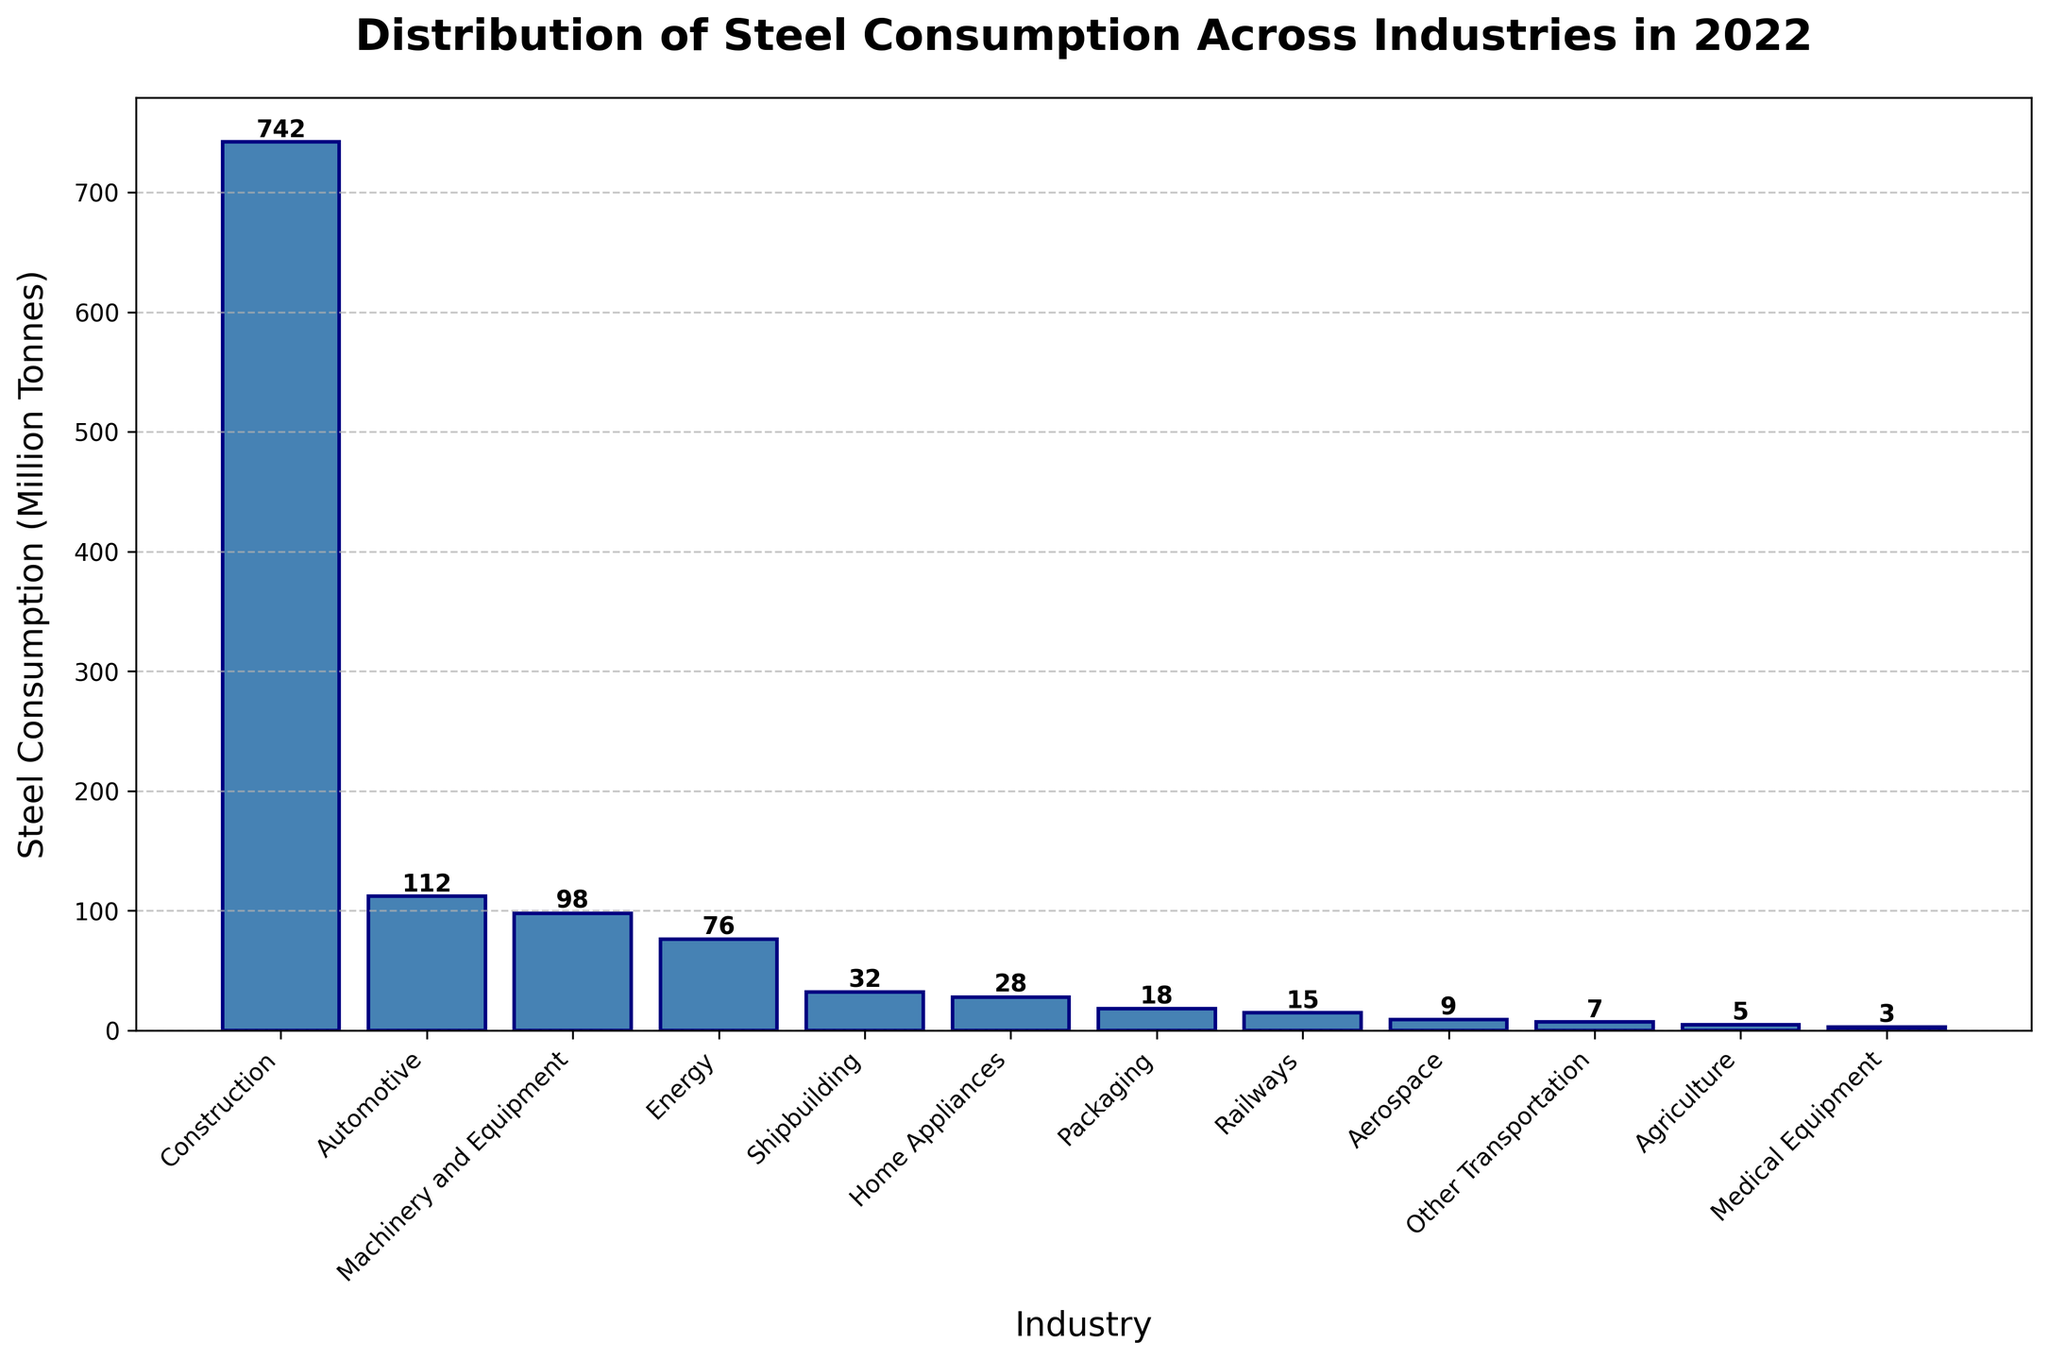What's the industry with the highest steel consumption? The bar representing "Construction" stands out as the tallest and has the highest value label.
Answer: Construction Which industry consumes more steel, Automotive or Machinery and Equipment? The bar for "Automotive" is taller and has a higher value label than the "Machinery and Equipment" bar.
Answer: Automotive What is the total steel consumption of the top 3 industries? The top 3 industries by steel consumption are "Construction" (742), "Automotive" (112), and "Machinery and Equipment" (98). Summing these values gives 742 + 112 + 98 = 952.
Answer: 952 million tonnes How much more steel does the Energy industry consume compared to the Shipbuilding industry? The Energy industry consumes 76 million tonnes, and the Shipbuilding industry consumes 32 million tonnes. The difference is 76 - 32 = 44 million tonnes.
Answer: 44 million tonnes What is the combined steel consumption of the least three consuming industries? The three industries with the lowest consumption are "Medical Equipment" (3), "Agriculture" (5), and "Other Transportation" (7). Summing these values gives 3 + 5 + 7 = 15 million tonnes.
Answer: 15 million tonnes Which industry consumes the least steel, and how much is it? The bar for "Medical Equipment" is the shortest and has the lowest value label at 3 million tonnes.
Answer: Medical Equipment, 3 million tonnes Compare the steel consumption between Railways and Aerospace. Which one is higher and by how much? The Railways industry consumes 15 million tonnes, and the Aerospace industry consumes 9 million tonnes. The difference is 15 - 9 = 6 million tonnes.
Answer: Railways, 6 million tonnes How does the steel consumption in Home Appliances compare to Packaging? The bar for "Home Appliances" is taller than the bar for "Packaging," indicating higher steel consumption. Specifically, Home Appliances consume 28 million tonnes, and Packaging consumes 18 million tonnes.
Answer: Home Appliances consumes more by 10 million tonnes What's the average steel consumption of the industries with over 50 million tonnes? Industries with over 50 million tonnes are "Construction" (742), "Automotive" (112), "Machinery and Equipment" (98), and "Energy" (76). Summing these values gives 742 + 112 + 98 + 76 = 1028. There are 4 industries, so the average is 1028 / 4 = 257 million tonnes.
Answer: 257 million tonnes 